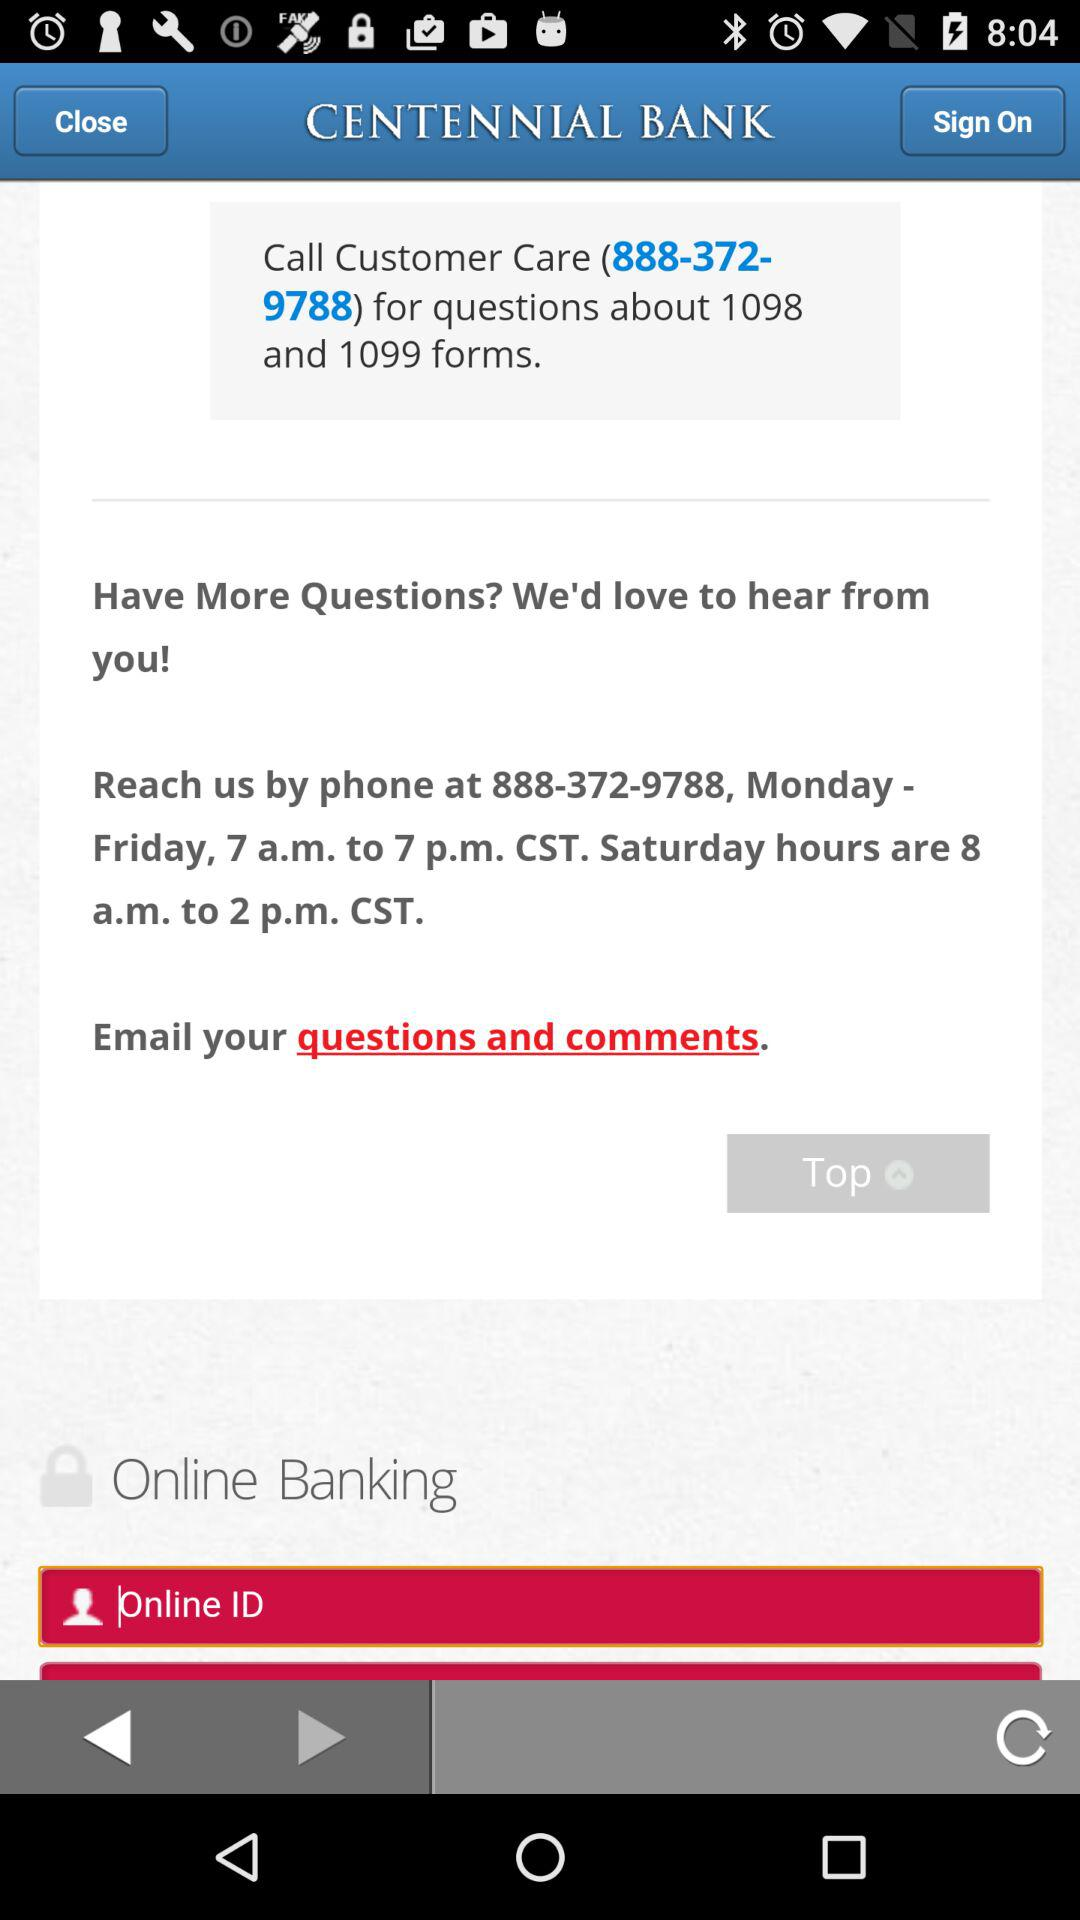How many text input fields are there on this screen?
Answer the question using a single word or phrase. 1 